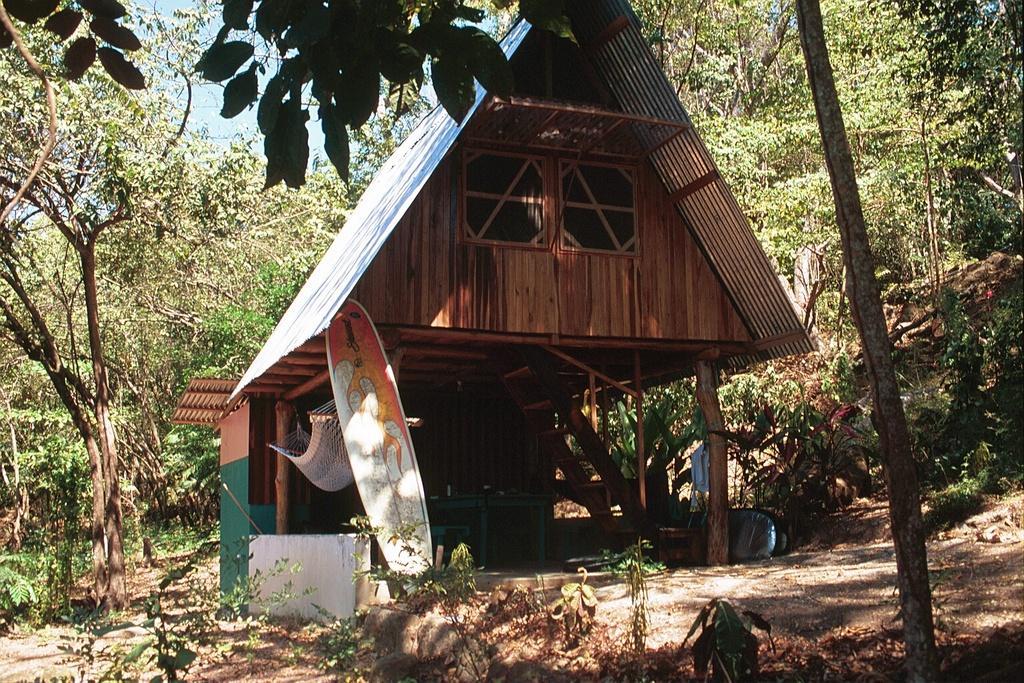How would you summarize this image in a sentence or two? In this image there is a hut having a swing attached to the wooden trunks. Before the but there is a surfboard. Background there are few plants and trees. 